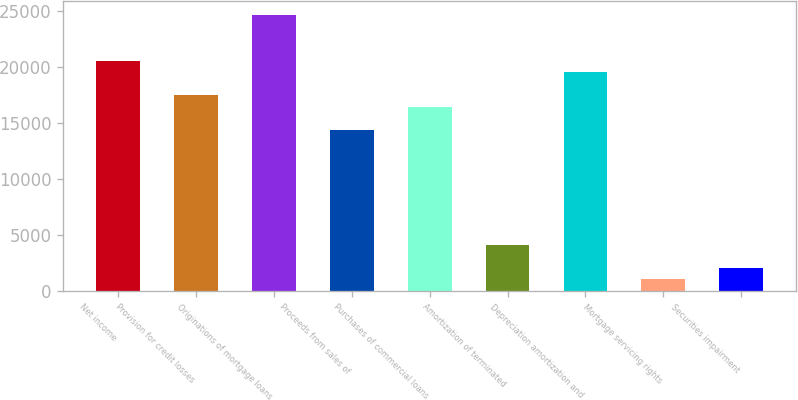Convert chart. <chart><loc_0><loc_0><loc_500><loc_500><bar_chart><fcel>Net income<fcel>Provision for credit losses<fcel>Originations of mortgage loans<fcel>Proceeds from sales of<fcel>Purchases of commercial loans<fcel>Amortization of terminated<fcel>Depreciation amortization and<fcel>Mortgage servicing rights<fcel>Securities impairment<nl><fcel>20545<fcel>17463.7<fcel>24653.4<fcel>14382.4<fcel>16436.6<fcel>4111.4<fcel>19517.9<fcel>1030.1<fcel>2057.2<nl></chart> 